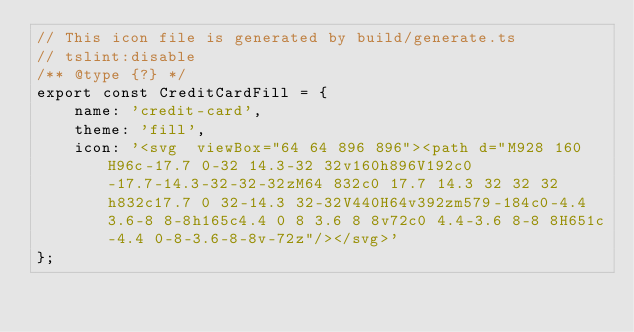Convert code to text. <code><loc_0><loc_0><loc_500><loc_500><_JavaScript_>// This icon file is generated by build/generate.ts
// tslint:disable
/** @type {?} */
export const CreditCardFill = {
    name: 'credit-card',
    theme: 'fill',
    icon: '<svg  viewBox="64 64 896 896"><path d="M928 160H96c-17.7 0-32 14.3-32 32v160h896V192c0-17.7-14.3-32-32-32zM64 832c0 17.7 14.3 32 32 32h832c17.7 0 32-14.3 32-32V440H64v392zm579-184c0-4.4 3.6-8 8-8h165c4.4 0 8 3.6 8 8v72c0 4.4-3.6 8-8 8H651c-4.4 0-8-3.6-8-8v-72z"/></svg>'
};</code> 